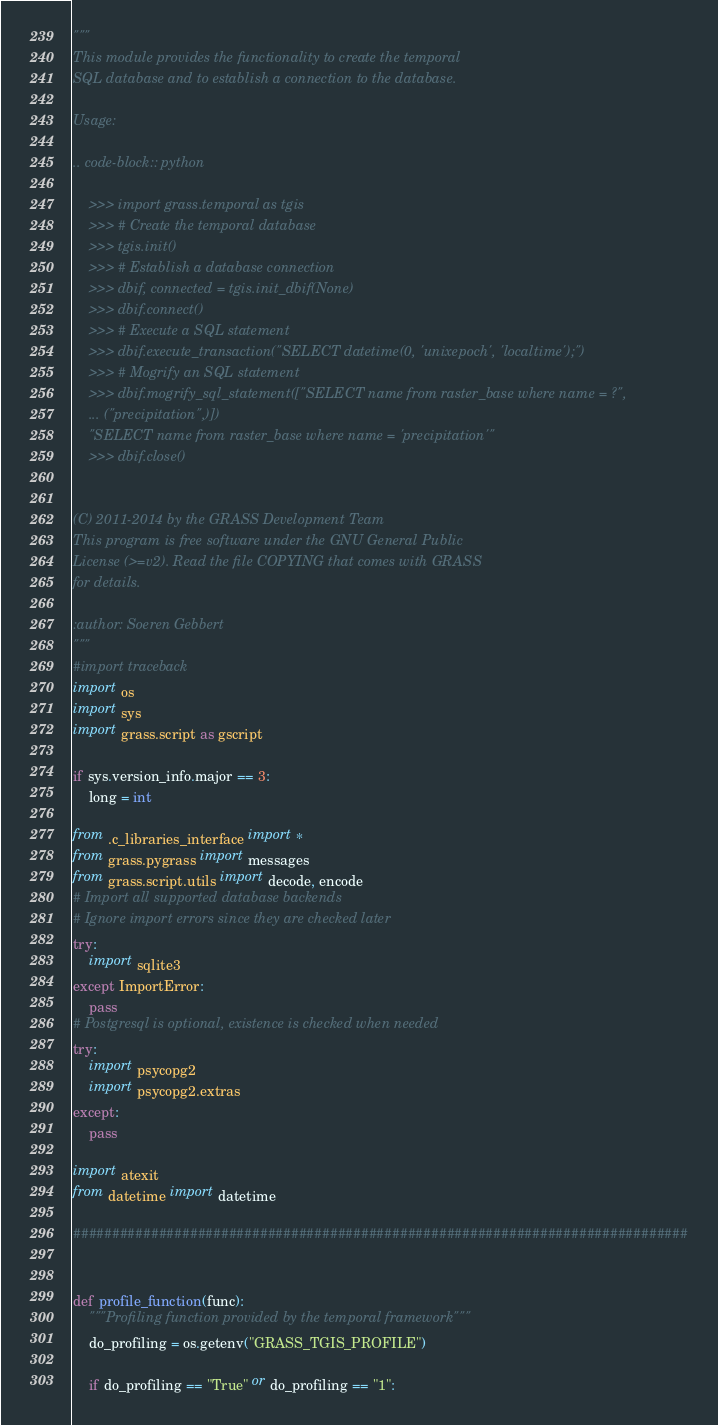Convert code to text. <code><loc_0><loc_0><loc_500><loc_500><_Python_>"""
This module provides the functionality to create the temporal
SQL database and to establish a connection to the database.

Usage:

.. code-block:: python

    >>> import grass.temporal as tgis
    >>> # Create the temporal database
    >>> tgis.init()
    >>> # Establish a database connection
    >>> dbif, connected = tgis.init_dbif(None)
    >>> dbif.connect()
    >>> # Execute a SQL statement
    >>> dbif.execute_transaction("SELECT datetime(0, 'unixepoch', 'localtime');")
    >>> # Mogrify an SQL statement
    >>> dbif.mogrify_sql_statement(["SELECT name from raster_base where name = ?",
    ... ("precipitation",)])
    "SELECT name from raster_base where name = 'precipitation'"
    >>> dbif.close()


(C) 2011-2014 by the GRASS Development Team
This program is free software under the GNU General Public
License (>=v2). Read the file COPYING that comes with GRASS
for details.

:author: Soeren Gebbert
"""
#import traceback
import os
import sys
import grass.script as gscript

if sys.version_info.major == 3:
    long = int

from .c_libraries_interface import *
from grass.pygrass import messages
from grass.script.utils import decode, encode
# Import all supported database backends
# Ignore import errors since they are checked later
try:
    import sqlite3
except ImportError:
    pass
# Postgresql is optional, existence is checked when needed
try:
    import psycopg2
    import psycopg2.extras
except:
    pass

import atexit
from datetime import datetime

###############################################################################


def profile_function(func):
    """Profiling function provided by the temporal framework"""
    do_profiling = os.getenv("GRASS_TGIS_PROFILE")

    if do_profiling == "True" or do_profiling == "1":</code> 